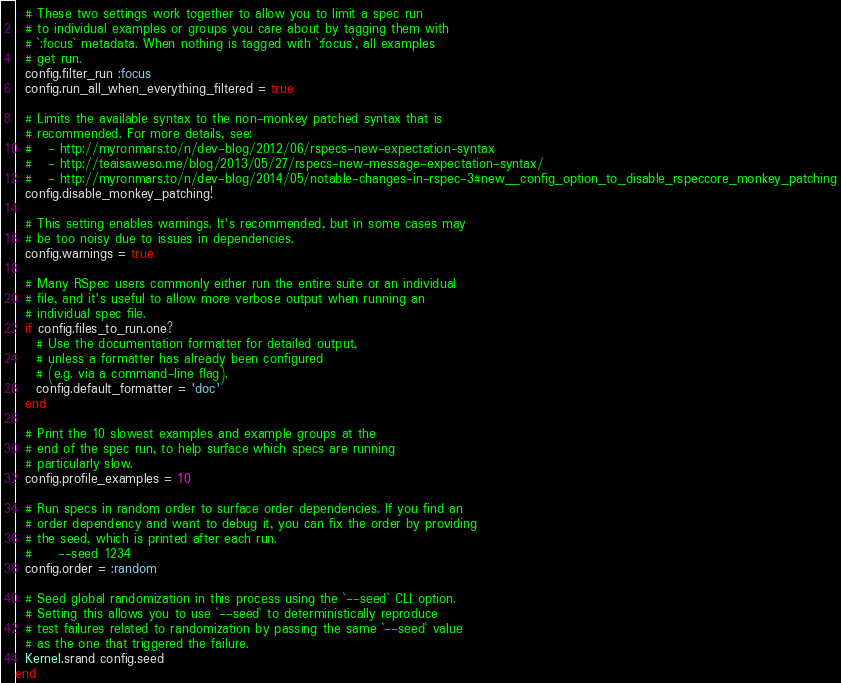Convert code to text. <code><loc_0><loc_0><loc_500><loc_500><_Ruby_>
  # These two settings work together to allow you to limit a spec run
  # to individual examples or groups you care about by tagging them with
  # `:focus` metadata. When nothing is tagged with `:focus`, all examples
  # get run.
  config.filter_run :focus
  config.run_all_when_everything_filtered = true

  # Limits the available syntax to the non-monkey patched syntax that is
  # recommended. For more details, see:
  #   - http://myronmars.to/n/dev-blog/2012/06/rspecs-new-expectation-syntax
  #   - http://teaisaweso.me/blog/2013/05/27/rspecs-new-message-expectation-syntax/
  #   - http://myronmars.to/n/dev-blog/2014/05/notable-changes-in-rspec-3#new__config_option_to_disable_rspeccore_monkey_patching
  config.disable_monkey_patching!

  # This setting enables warnings. It's recommended, but in some cases may
  # be too noisy due to issues in dependencies.
  config.warnings = true

  # Many RSpec users commonly either run the entire suite or an individual
  # file, and it's useful to allow more verbose output when running an
  # individual spec file.
  if config.files_to_run.one?
    # Use the documentation formatter for detailed output,
    # unless a formatter has already been configured
    # (e.g. via a command-line flag).
    config.default_formatter = 'doc'
  end

  # Print the 10 slowest examples and example groups at the
  # end of the spec run, to help surface which specs are running
  # particularly slow.
  config.profile_examples = 10

  # Run specs in random order to surface order dependencies. If you find an
  # order dependency and want to debug it, you can fix the order by providing
  # the seed, which is printed after each run.
  #     --seed 1234
  config.order = :random

  # Seed global randomization in this process using the `--seed` CLI option.
  # Setting this allows you to use `--seed` to deterministically reproduce
  # test failures related to randomization by passing the same `--seed` value
  # as the one that triggered the failure.
  Kernel.srand config.seed
end
</code> 